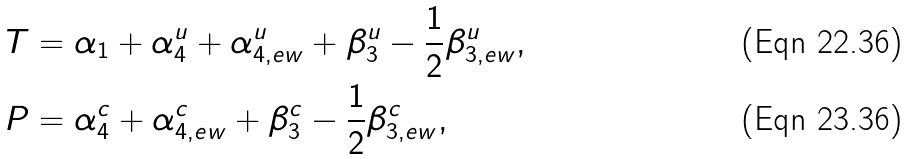Convert formula to latex. <formula><loc_0><loc_0><loc_500><loc_500>T & = \alpha _ { 1 } + \alpha _ { 4 } ^ { u } + \alpha _ { 4 , e w } ^ { u } + \beta _ { 3 } ^ { u } - \frac { 1 } { 2 } \beta _ { 3 , e w } ^ { u } , \\ P & = \alpha _ { 4 } ^ { c } + \alpha _ { 4 , e w } ^ { c } + \beta _ { 3 } ^ { c } - \frac { 1 } { 2 } \beta _ { 3 , e w } ^ { c } ,</formula> 